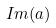<formula> <loc_0><loc_0><loc_500><loc_500>I m ( a )</formula> 